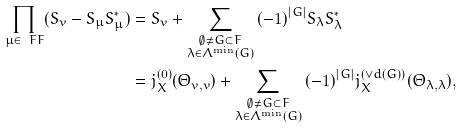<formula> <loc_0><loc_0><loc_500><loc_500>\prod _ { \mu \in \ F F } ( S _ { v } - S _ { \mu } S _ { \mu } ^ { * } ) & = S _ { v } + \sum _ { \substack { \emptyset \not = G \subset F \\ \lambda \in \Lambda ^ { \min } ( G ) } } { ( - 1 ) } ^ { | G | } S _ { \lambda } S _ { \lambda } ^ { * } \\ & = j _ { X } ^ { ( 0 ) } ( \Theta _ { v , v } ) + \sum _ { \substack { \emptyset \not = G \subset F \\ \lambda \in \Lambda ^ { \min } ( G ) } } { ( - 1 ) } ^ { | G | } j _ { X } ^ { ( \vee d ( G ) ) } ( \Theta _ { \lambda , \lambda } ) ,</formula> 